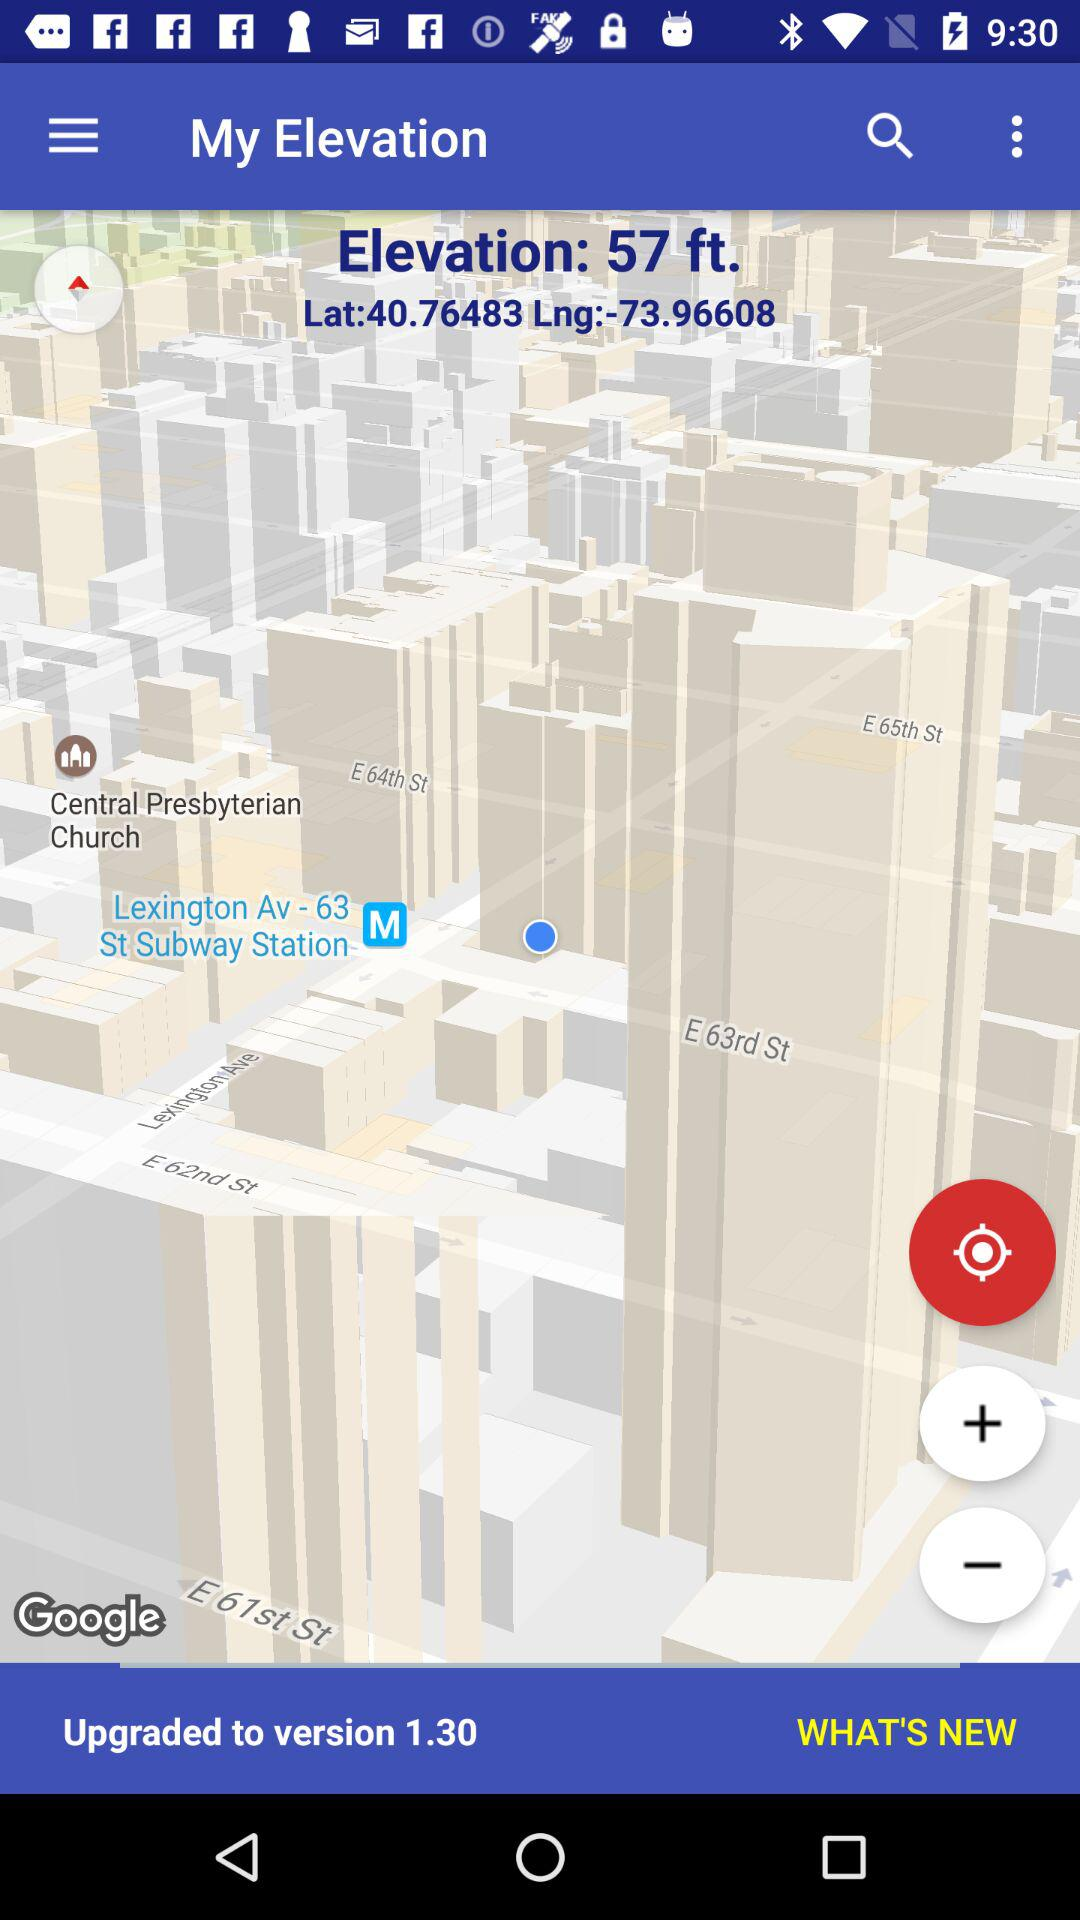Which version has it been upgraded to? It has been upgraded to version 1.30. 